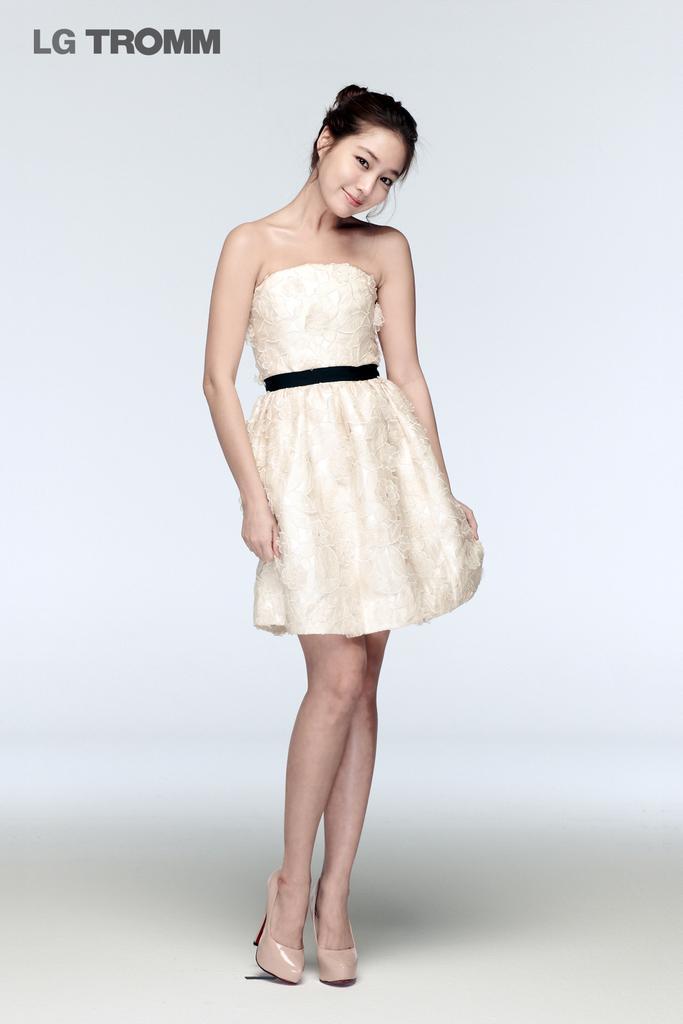In one or two sentences, can you explain what this image depicts? In the picture we can see a photograph of a woman standing in the high heels and cream color dress and she is smiling and slightly bending her head and on the top of it we can see a name LG TROMM. 